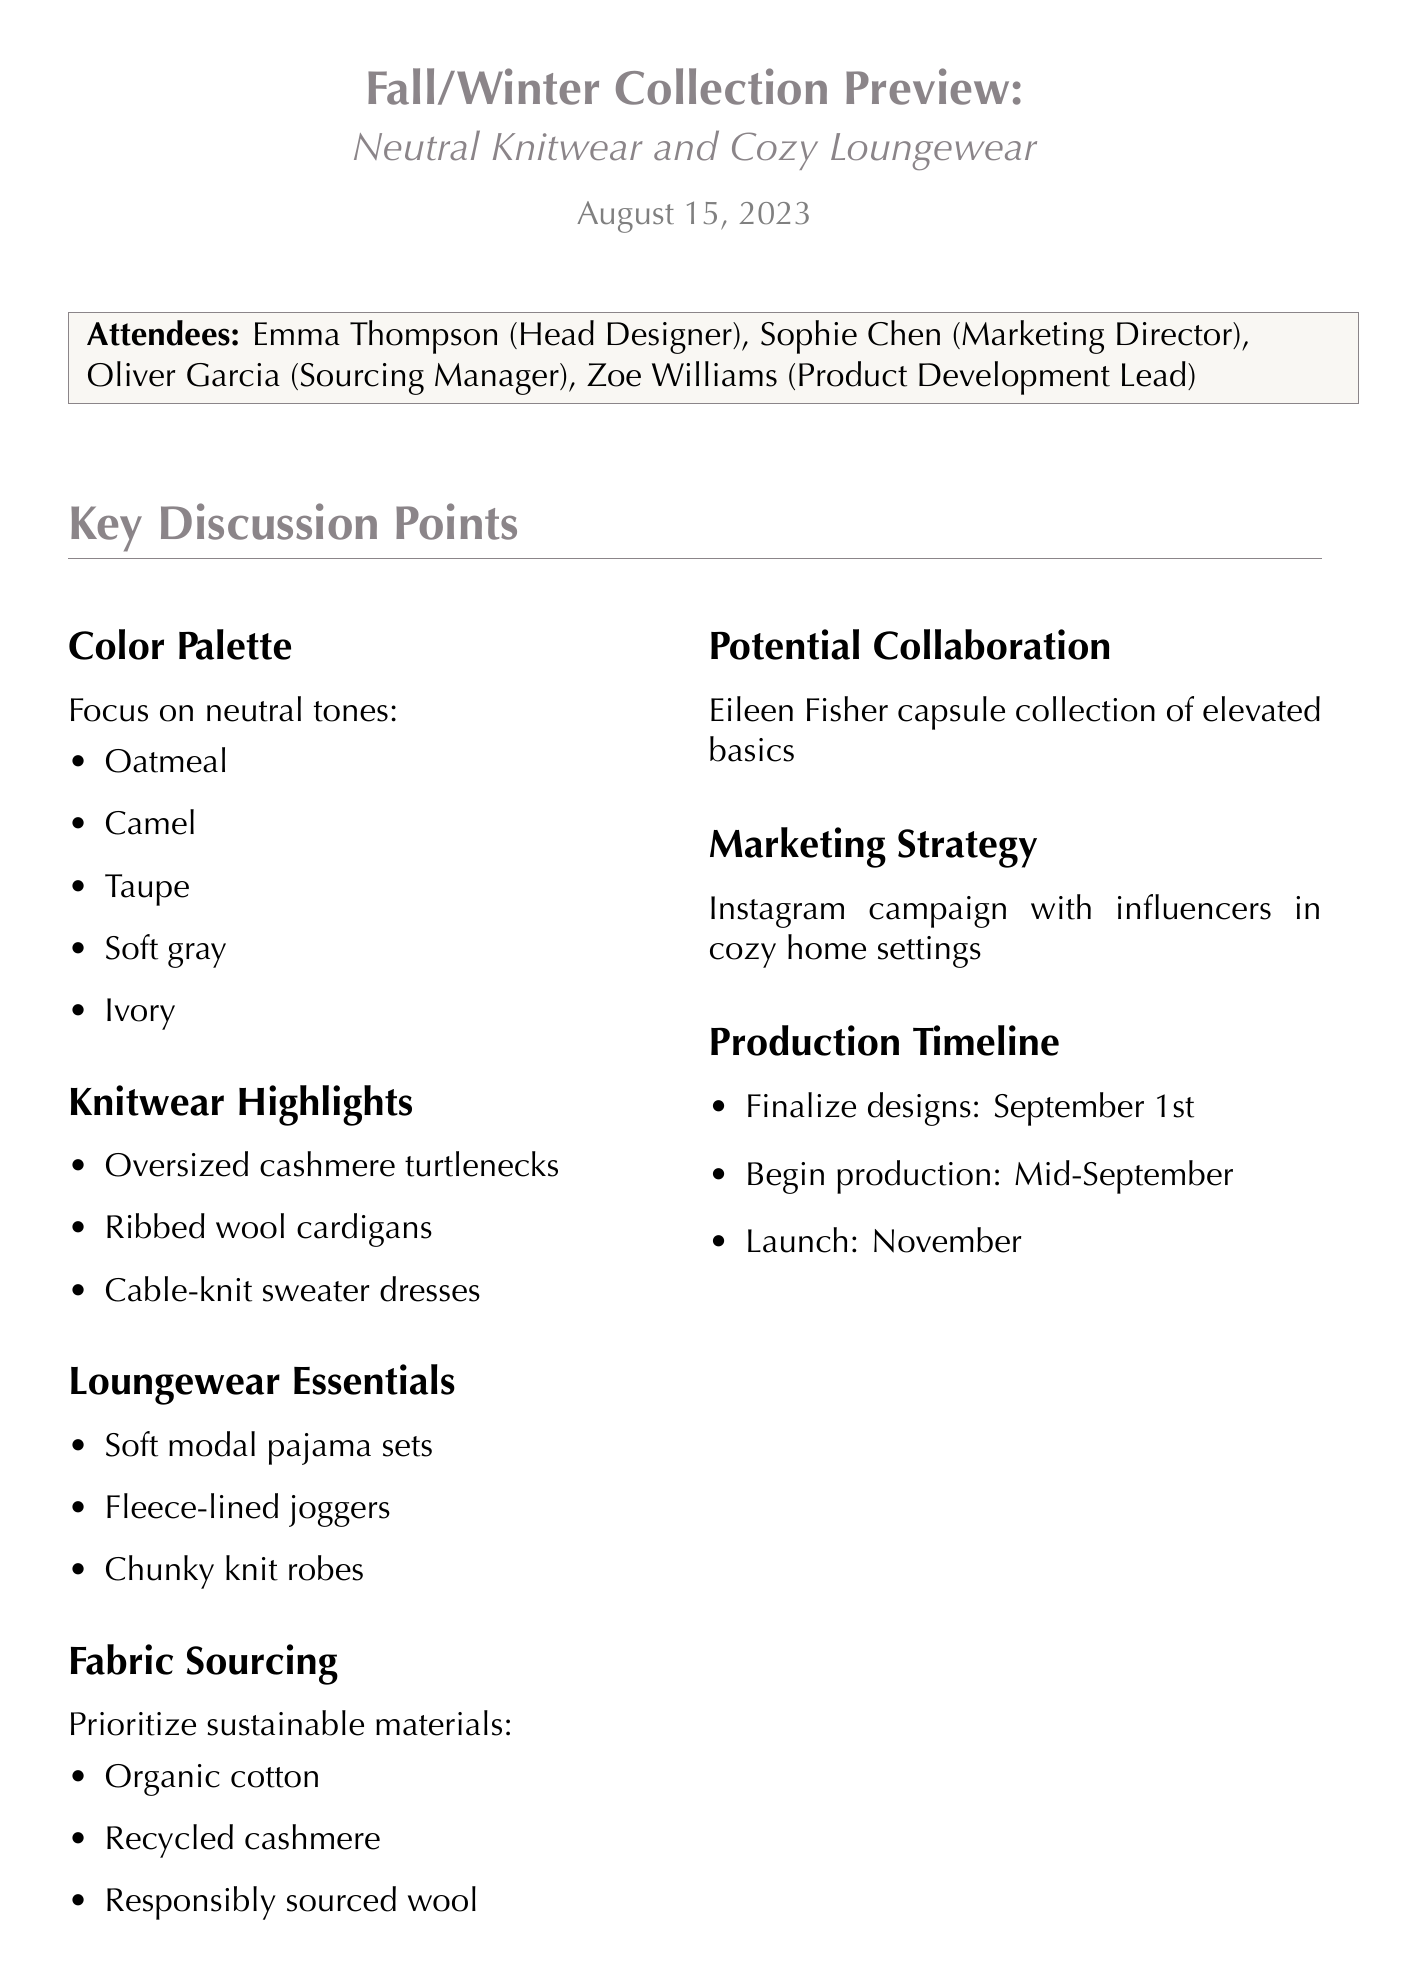What is the date of the meeting? The date of the meeting is mentioned at the beginning of the document.
Answer: August 15, 2023 Who is the Head Designer? The Head Designer is listed in the attendees section of the document.
Answer: Emma Thompson What are the neutral tones highlighted in the color palette? The document lists specific colors included in the color palette section.
Answer: oatmeal, camel, taupe, soft gray, and ivory How many key knitwear pieces are listed? The number of pieces can be counted in the Key Knitwear Pieces section.
Answer: Three Which fabric is prioritized for sourcing? The document indicates specific materials for sourcing under fabric sourcing.
Answer: organic cotton What is the planned launch month for the collection? The planned launch month is detailed in the production timeline section of the document.
Answer: November What is the action item for Oliver? The specific task assigned to Oliver is included in the action items list.
Answer: Contact sustainable fabric suppliers for samples What type of marketing strategy is mentioned? The marketing strategy is outlined in the marketing strategy section of the document.
Answer: Instagram campaign Who are the potential collaborators for the collection? The potential collaboration is noted in the potential collaboration section of the document.
Answer: Eileen Fisher 